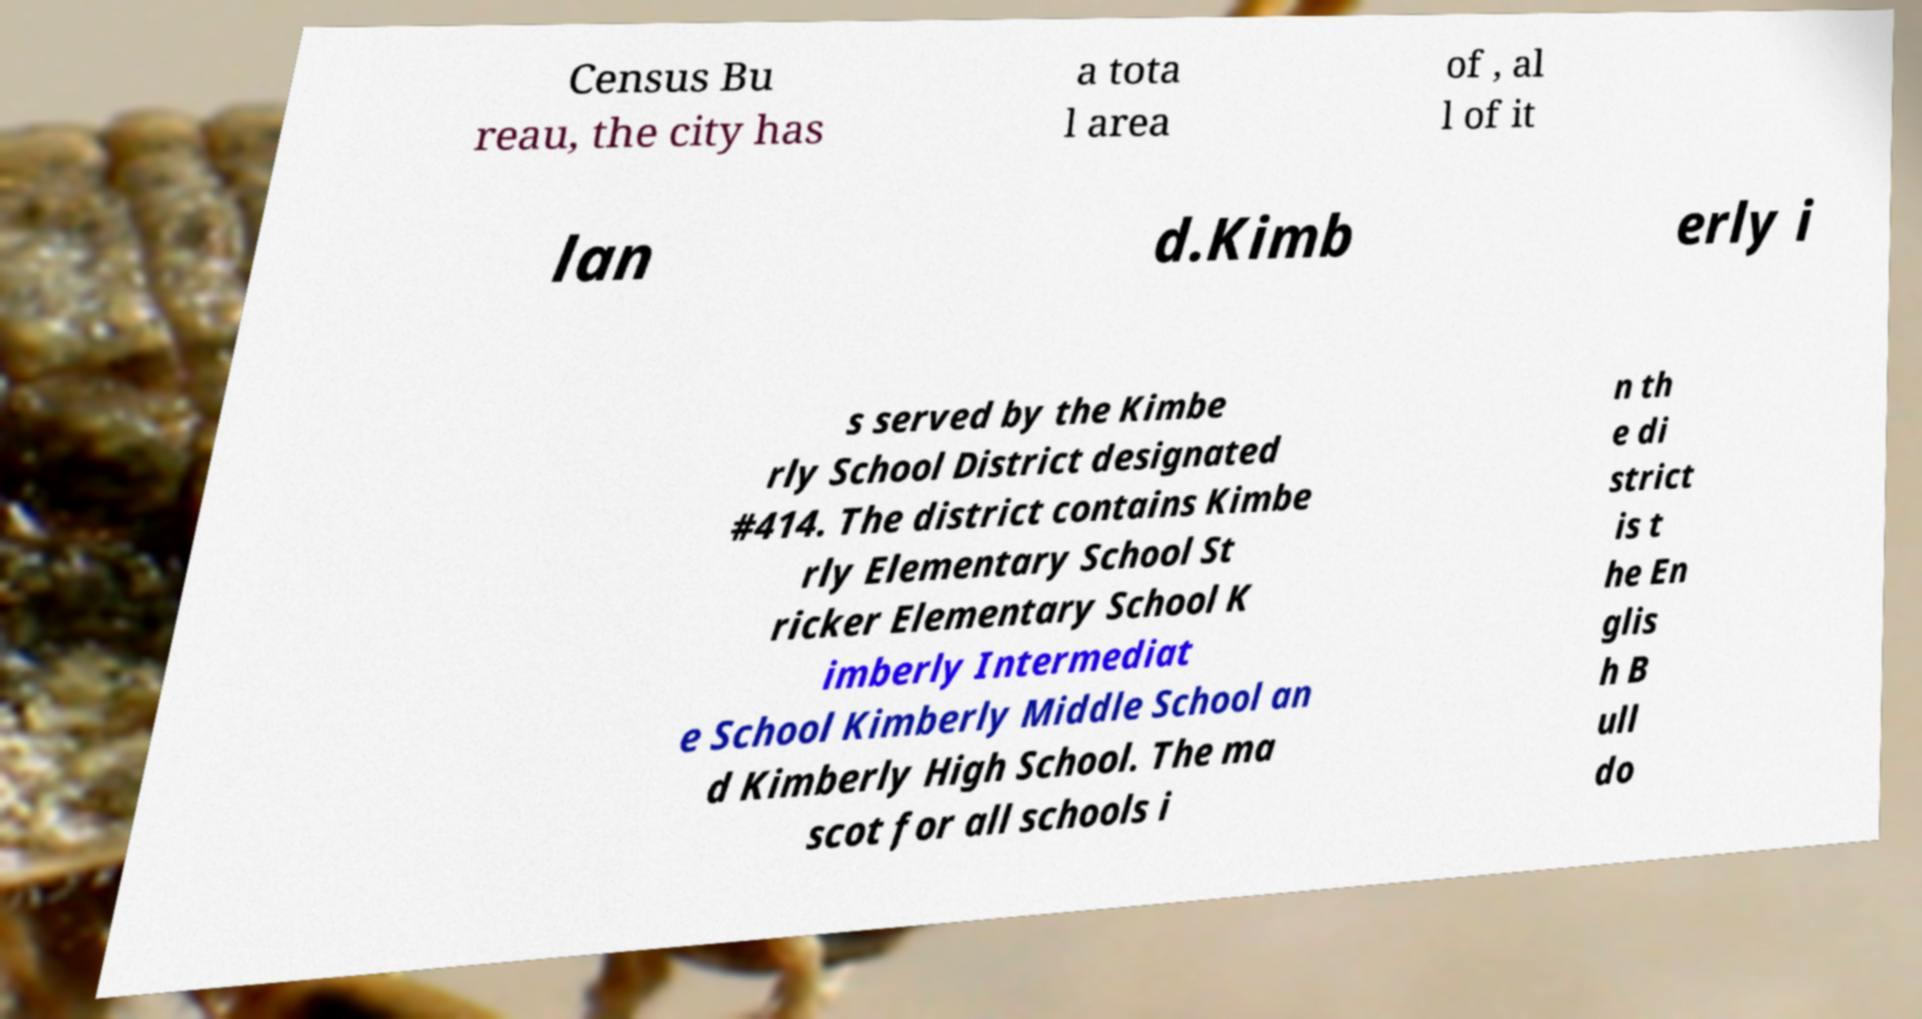I need the written content from this picture converted into text. Can you do that? Census Bu reau, the city has a tota l area of , al l of it lan d.Kimb erly i s served by the Kimbe rly School District designated #414. The district contains Kimbe rly Elementary School St ricker Elementary School K imberly Intermediat e School Kimberly Middle School an d Kimberly High School. The ma scot for all schools i n th e di strict is t he En glis h B ull do 